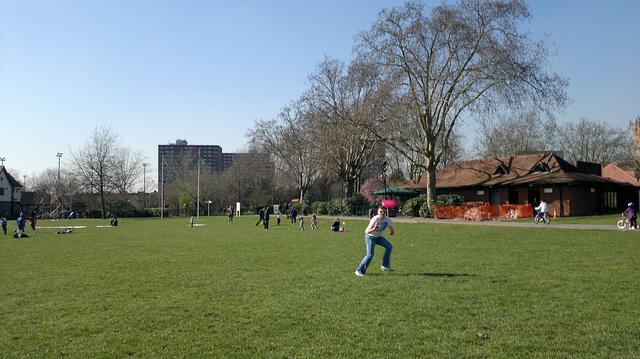Is the house huge?
Give a very brief answer. Yes. What color is the frisbee?
Write a very short answer. Red. What's the weather like?
Concise answer only. Sunny. Is there a person on a bike?
Give a very brief answer. Yes. Why are they surrounded by trees?
Quick response, please. In park. What is in the air?
Be succinct. Frisbee. Is it very cold in this photo?
Quick response, please. No. 